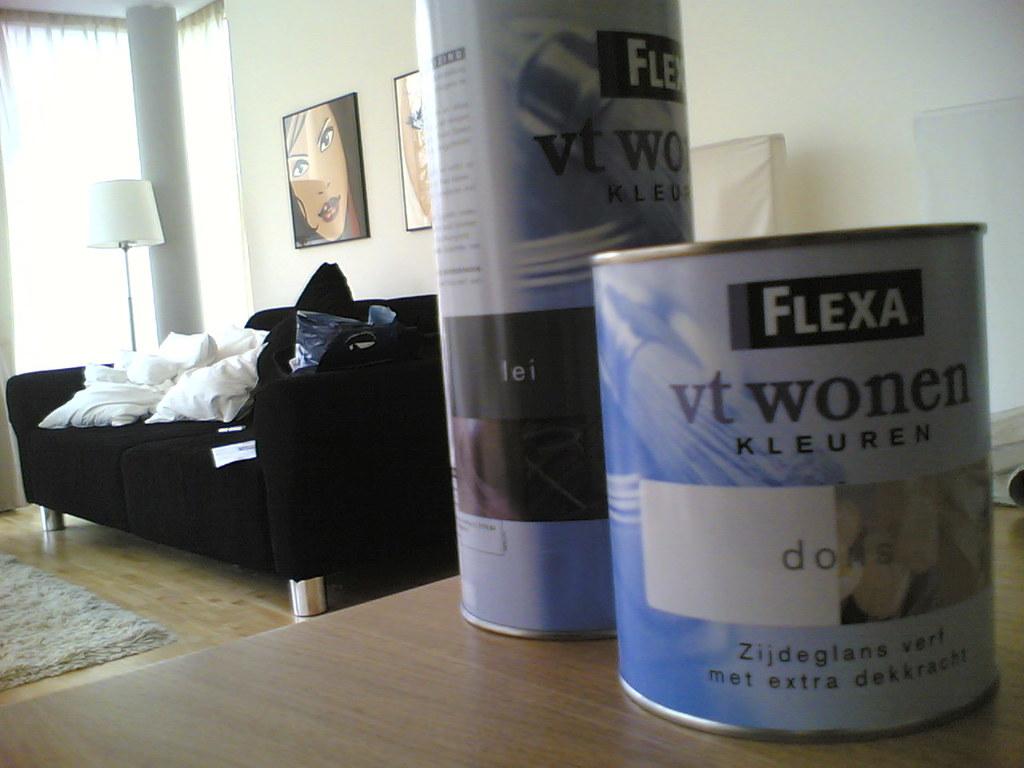What brand is that?
Keep it short and to the point. Flexa. 